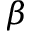Convert formula to latex. <formula><loc_0><loc_0><loc_500><loc_500>\beta</formula> 